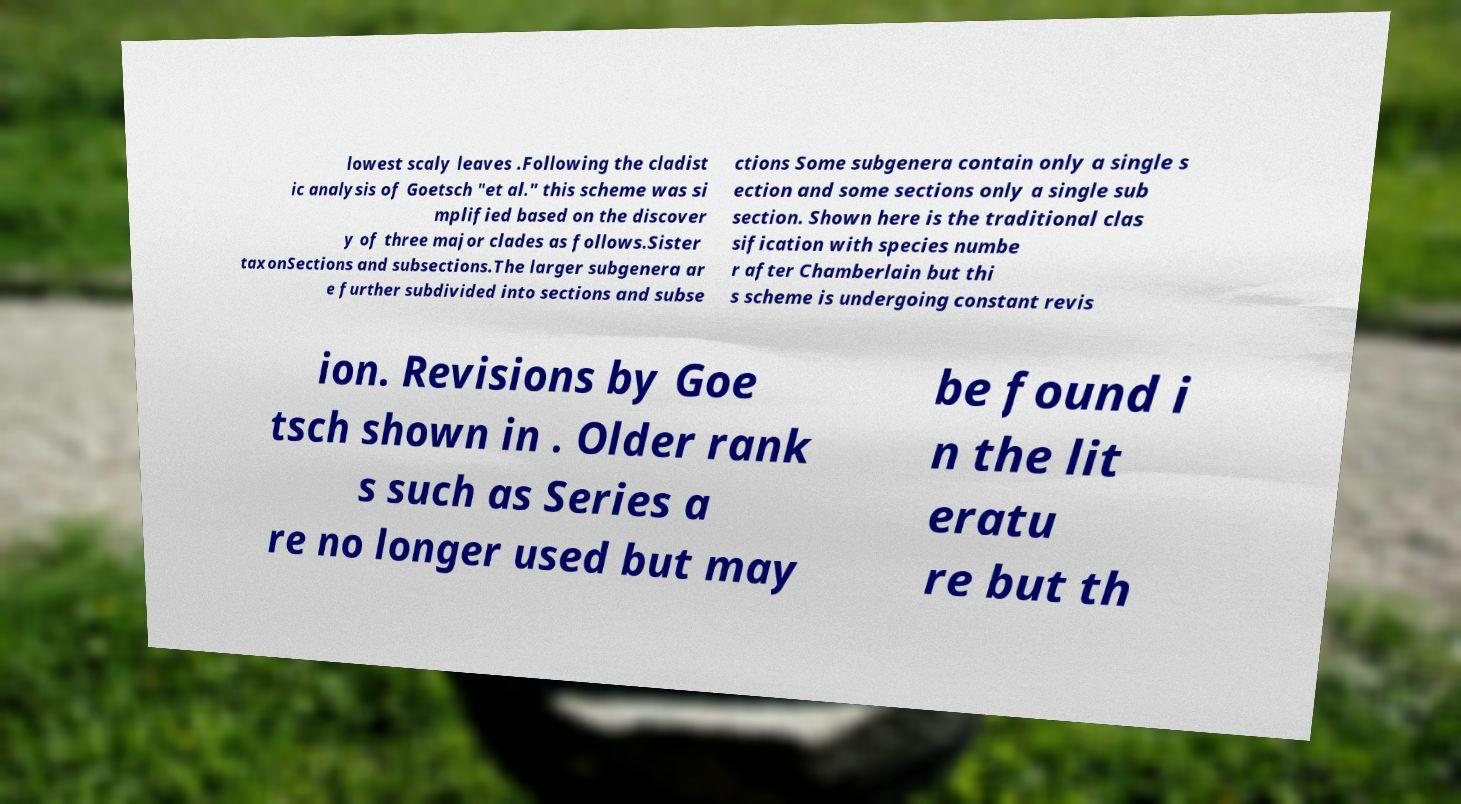I need the written content from this picture converted into text. Can you do that? lowest scaly leaves .Following the cladist ic analysis of Goetsch "et al." this scheme was si mplified based on the discover y of three major clades as follows.Sister taxonSections and subsections.The larger subgenera ar e further subdivided into sections and subse ctions Some subgenera contain only a single s ection and some sections only a single sub section. Shown here is the traditional clas sification with species numbe r after Chamberlain but thi s scheme is undergoing constant revis ion. Revisions by Goe tsch shown in . Older rank s such as Series a re no longer used but may be found i n the lit eratu re but th 